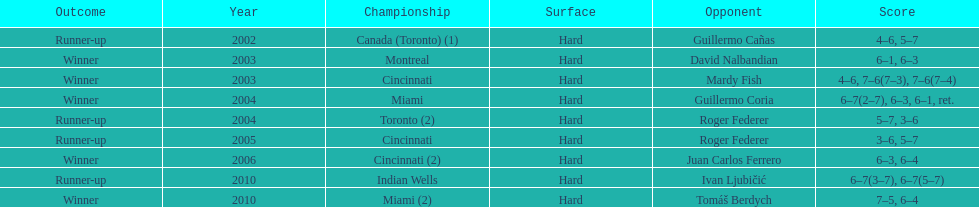What was the highest number of consecutive wins? 3. 